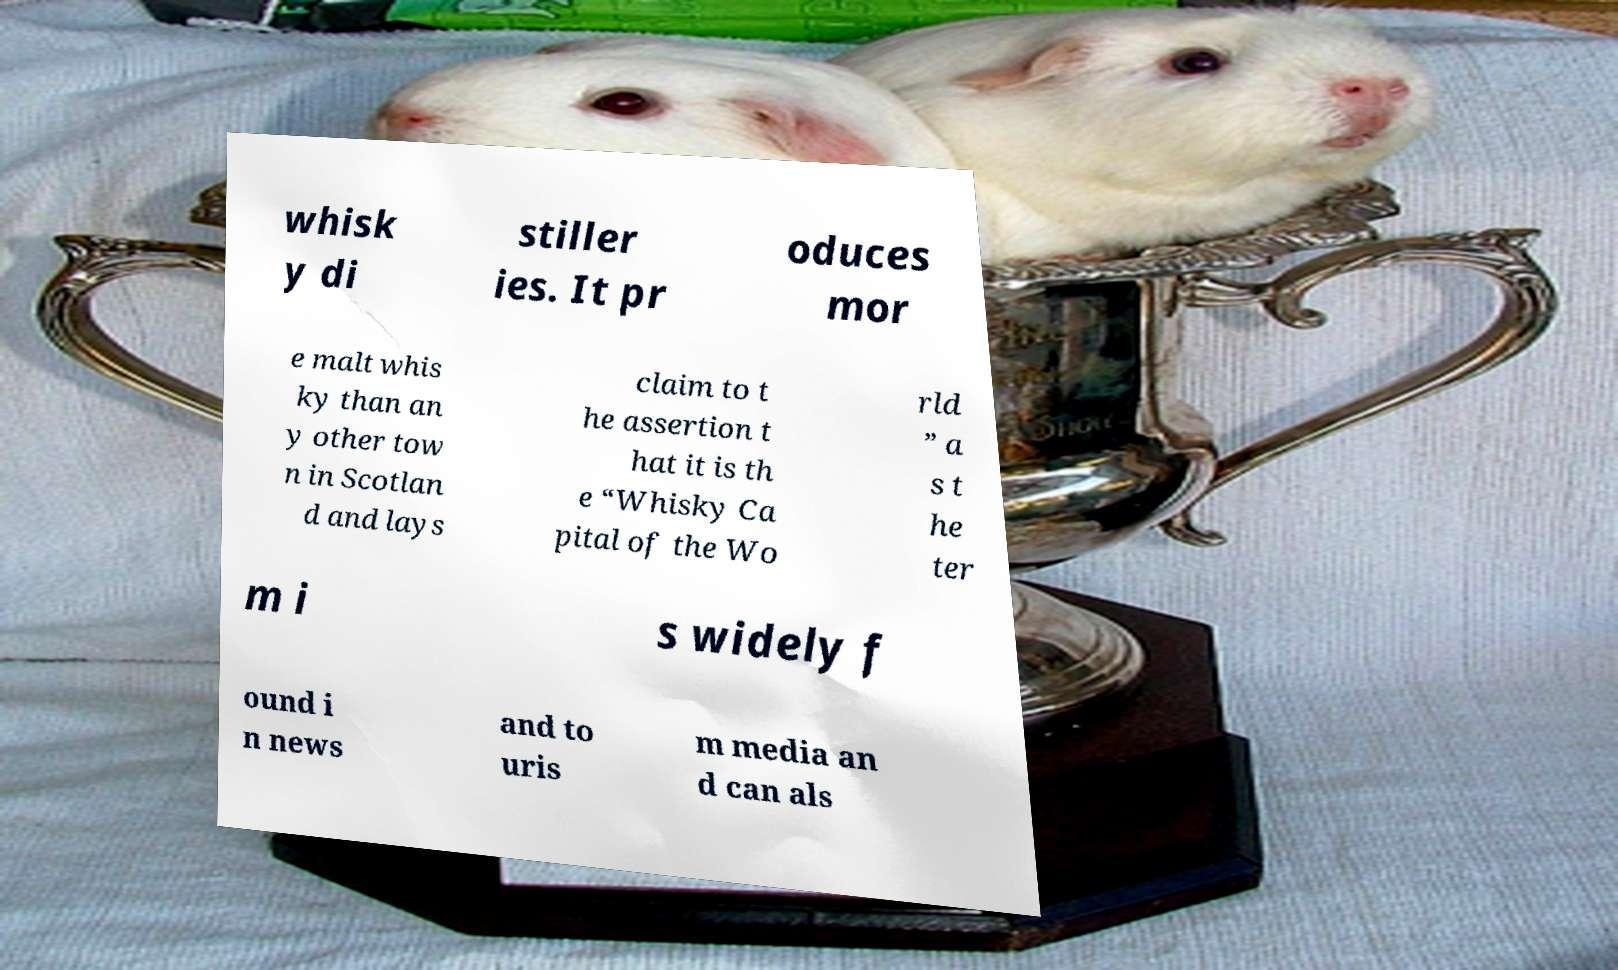Could you extract and type out the text from this image? whisk y di stiller ies. It pr oduces mor e malt whis ky than an y other tow n in Scotlan d and lays claim to t he assertion t hat it is th e “Whisky Ca pital of the Wo rld ” a s t he ter m i s widely f ound i n news and to uris m media an d can als 